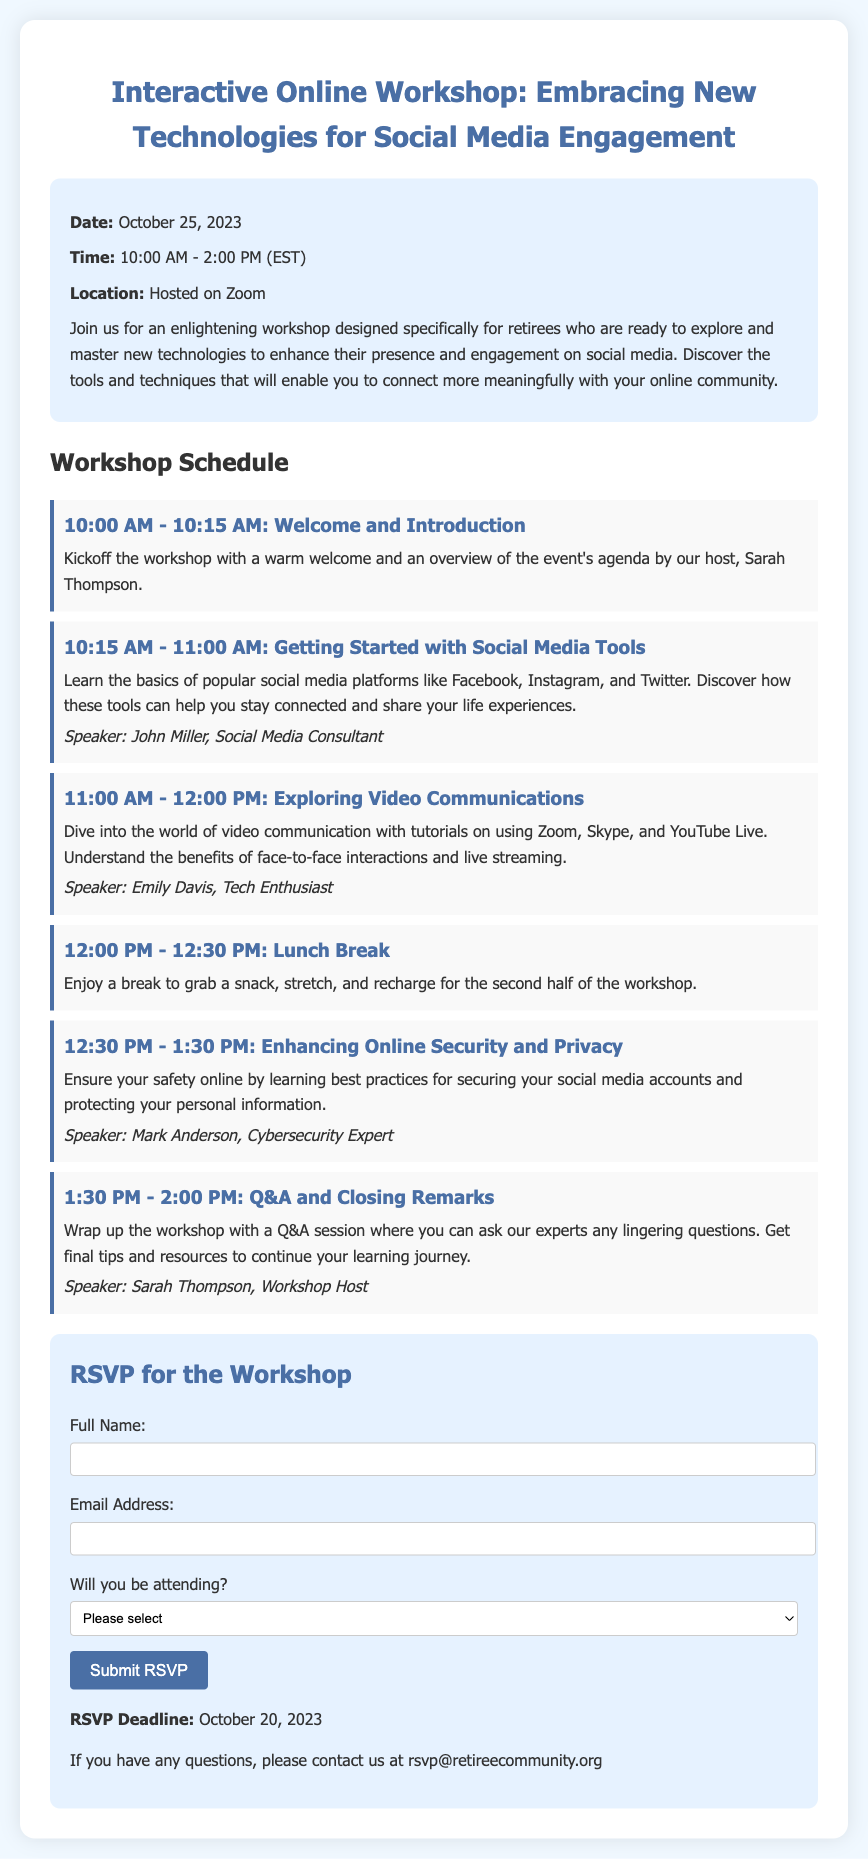What is the date of the workshop? The workshop is scheduled for October 25, 2023, as mentioned in the event details.
Answer: October 25, 2023 What time does the workshop start? The start time of the workshop is provided in the event details.
Answer: 10:00 AM Who is the host of the workshop? The name of the host is mentioned in the introduction of the workshop schedule.
Answer: Sarah Thompson How long is the lunch break? The lunch break duration is specified in the schedule section of the document.
Answer: 30 minutes What platform will the workshop be hosted on? The location of the workshop is indicated in the event details section.
Answer: Zoom When is the RSVP deadline? The RSVP deadline is stated in the RSVP form section of the document.
Answer: October 20, 2023 What is the name of the speaker for the first session? The speaker for the first session is identified in the schedule item for the session.
Answer: John Miller What question can I ask during the Q&A session? The Q&A session is noted for wrapping up the workshop, where participants can ask any lingering questions.
Answer: Any lingering questions What is the purpose of this workshop? The purpose of the workshop is outlined in the introduction, highlighting its focus on technologies for social media engagement.
Answer: Enhance presence and engagement on social media 